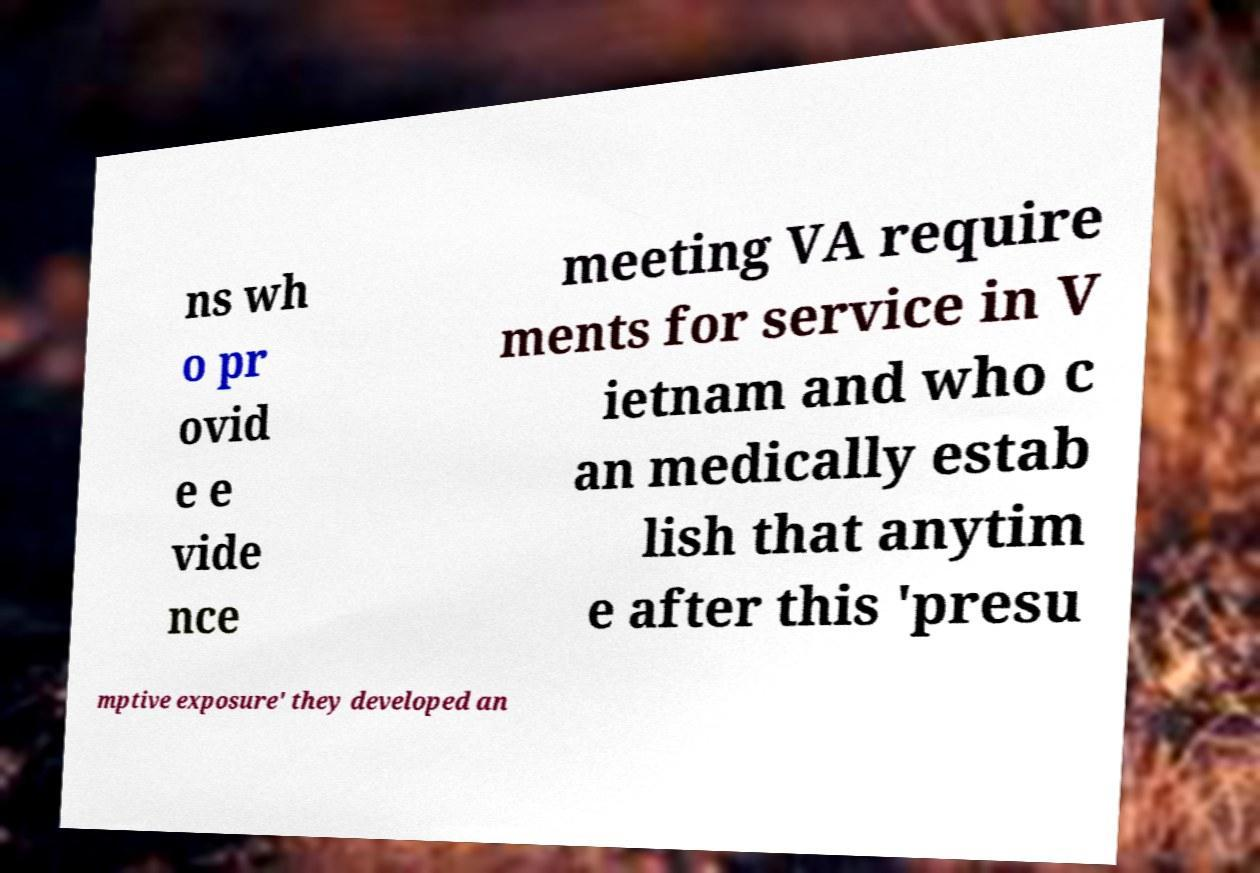For documentation purposes, I need the text within this image transcribed. Could you provide that? ns wh o pr ovid e e vide nce meeting VA require ments for service in V ietnam and who c an medically estab lish that anytim e after this 'presu mptive exposure' they developed an 